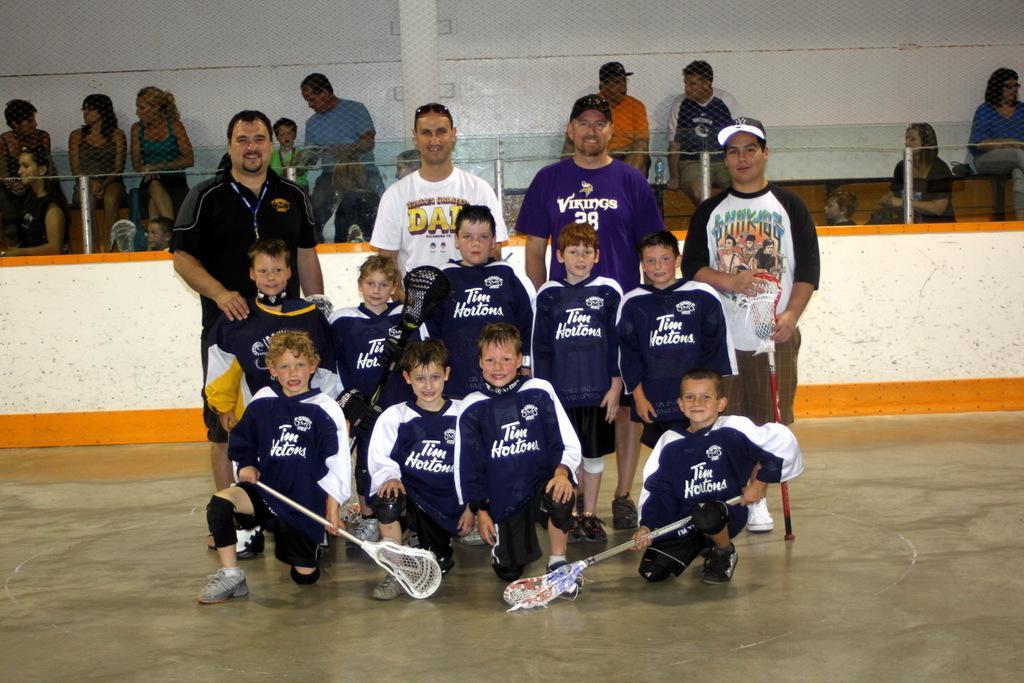Can you describe this image briefly? In the image there are few kids sitting and standing on the floor, they all wearing same jersey and behind them there are four men standing, in the back there is a fence with many people standing behind it. 